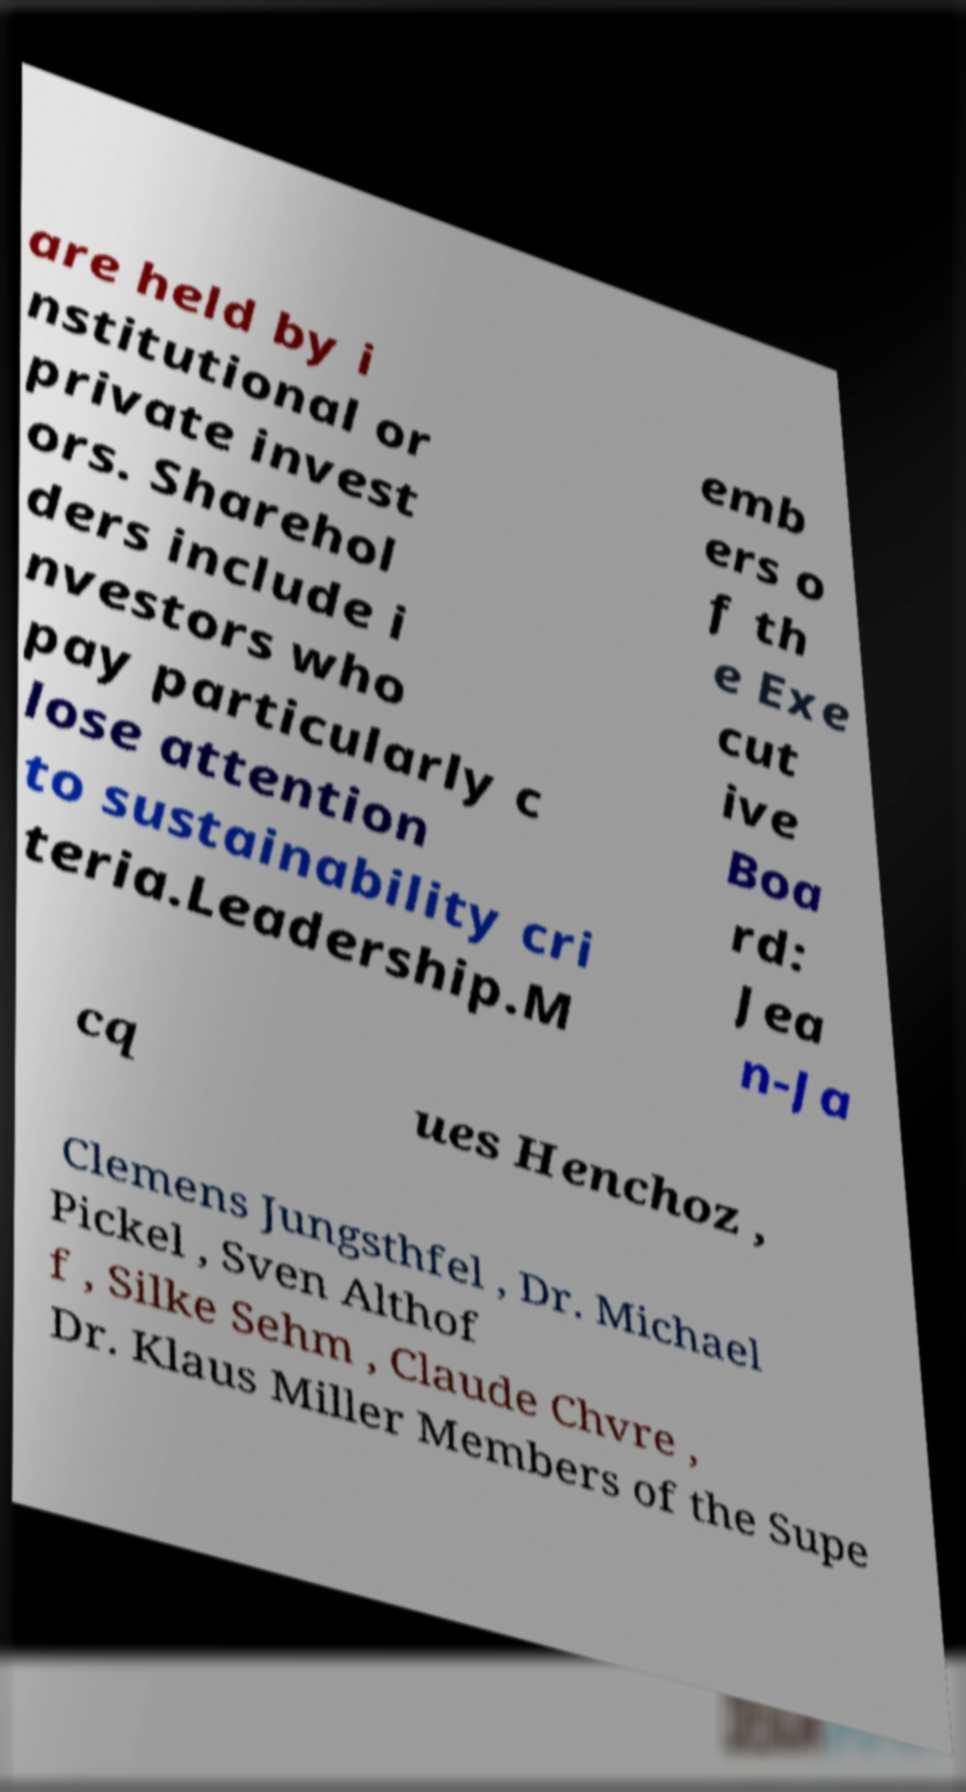Can you accurately transcribe the text from the provided image for me? are held by i nstitutional or private invest ors. Sharehol ders include i nvestors who pay particularly c lose attention to sustainability cri teria.Leadership.M emb ers o f th e Exe cut ive Boa rd: Jea n-Ja cq ues Henchoz , Clemens Jungsthfel , Dr. Michael Pickel , Sven Althof f , Silke Sehm , Claude Chvre , Dr. Klaus Miller Members of the Supe 